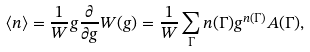<formula> <loc_0><loc_0><loc_500><loc_500>\langle n \rangle = \frac { 1 } { W } g \frac { \partial } { \partial g } W ( g ) = \frac { 1 } { W } \sum _ { \Gamma } n ( \Gamma ) g ^ { n ( \Gamma ) } A ( \Gamma ) ,</formula> 